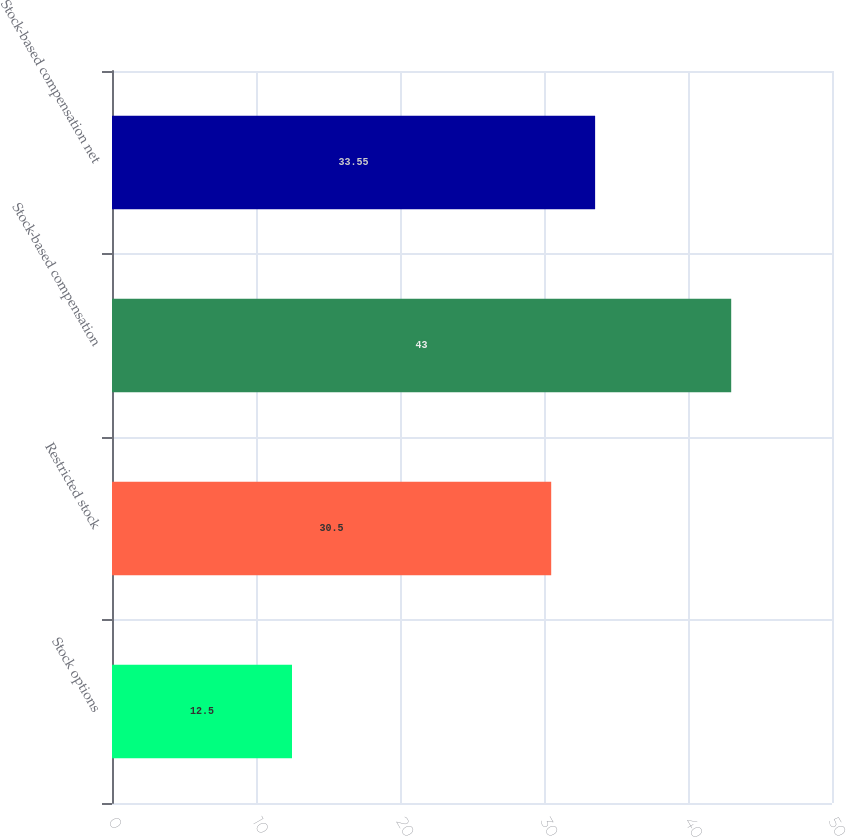<chart> <loc_0><loc_0><loc_500><loc_500><bar_chart><fcel>Stock options<fcel>Restricted stock<fcel>Stock-based compensation<fcel>Stock-based compensation net<nl><fcel>12.5<fcel>30.5<fcel>43<fcel>33.55<nl></chart> 